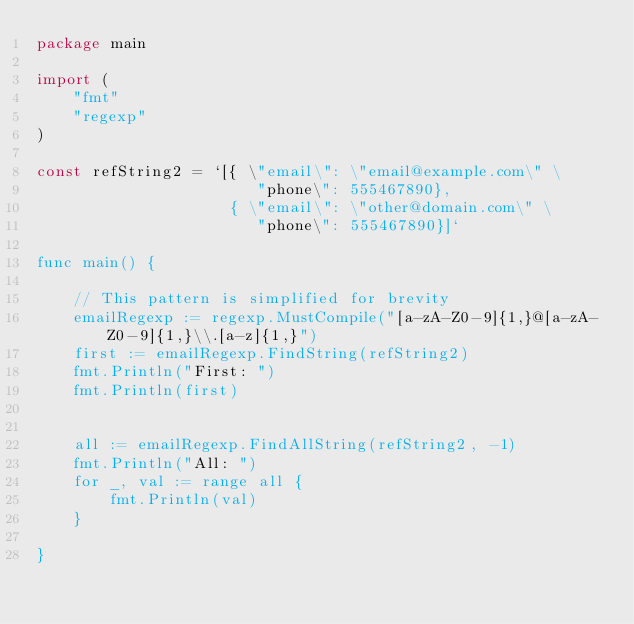Convert code to text. <code><loc_0><loc_0><loc_500><loc_500><_Go_>package main

import (
	"fmt"
	"regexp"
)

const refString2 = `[{ \"email\": \"email@example.com\" \
				   	    "phone\": 555467890},
                     { \"email\": \"other@domain.com\" \
                        "phone\": 555467890}]`

func main() {

	// This pattern is simplified for brevity
	emailRegexp := regexp.MustCompile("[a-zA-Z0-9]{1,}@[a-zA-Z0-9]{1,}\\.[a-z]{1,}")
	first := emailRegexp.FindString(refString2)
	fmt.Println("First: ")
	fmt.Println(first)


	all := emailRegexp.FindAllString(refString2, -1)
	fmt.Println("All: ")
	for _, val := range all {
		fmt.Println(val)
	}

}</code> 